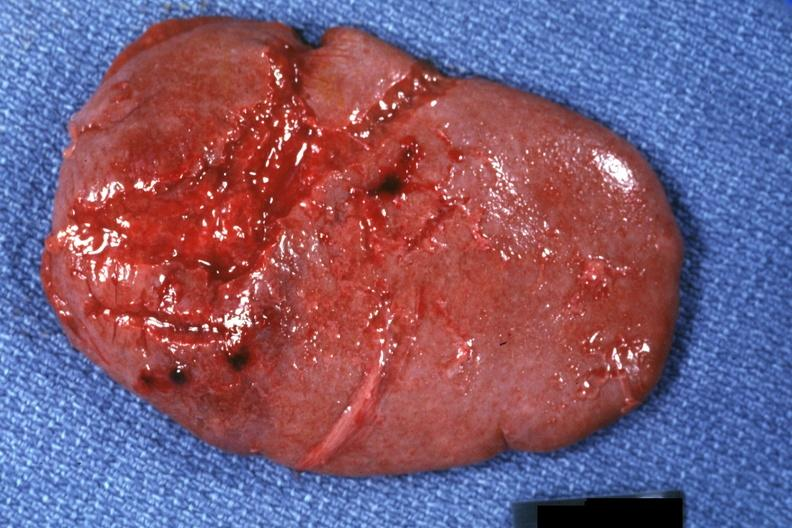s hematologic present?
Answer the question using a single word or phrase. Yes 